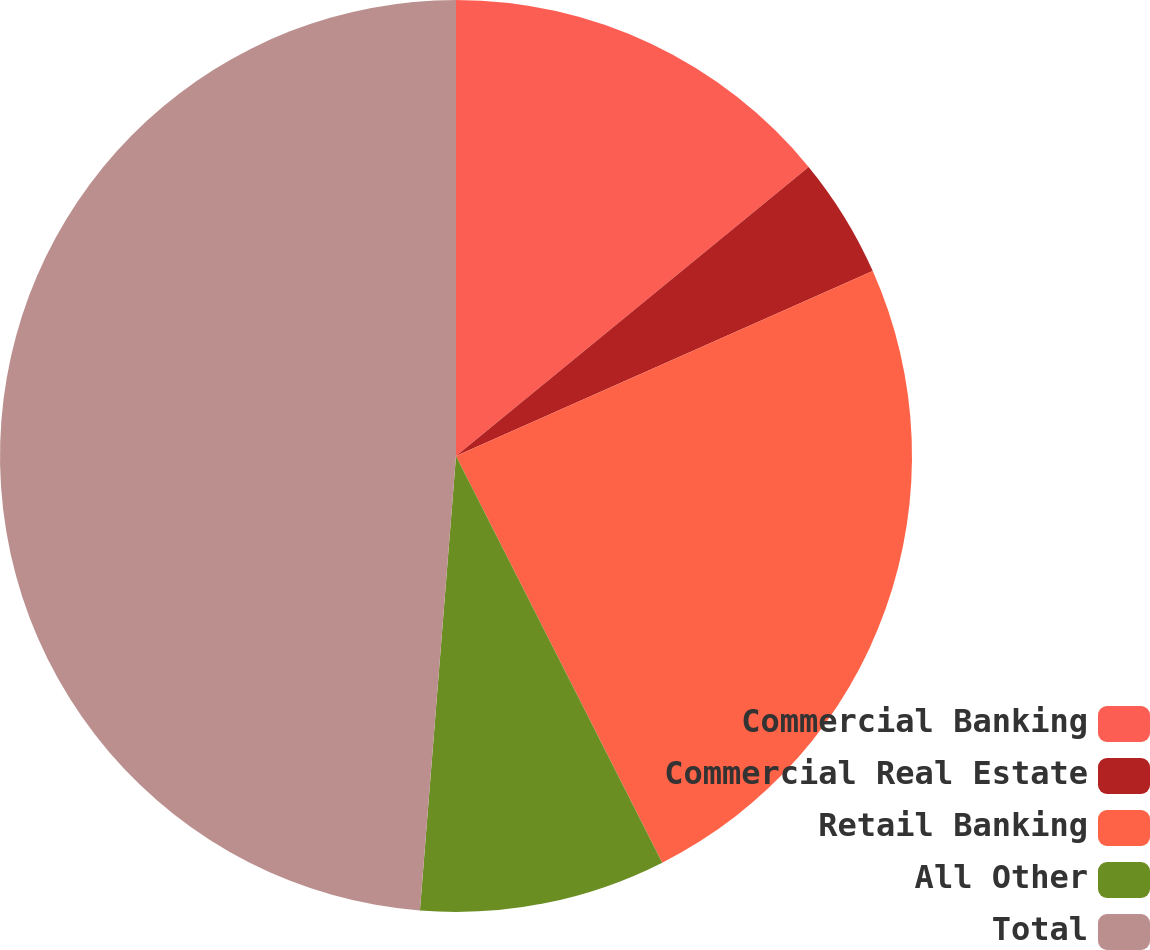Convert chart to OTSL. <chart><loc_0><loc_0><loc_500><loc_500><pie_chart><fcel>Commercial Banking<fcel>Commercial Real Estate<fcel>Retail Banking<fcel>All Other<fcel>Total<nl><fcel>14.07%<fcel>4.28%<fcel>24.18%<fcel>8.73%<fcel>48.74%<nl></chart> 